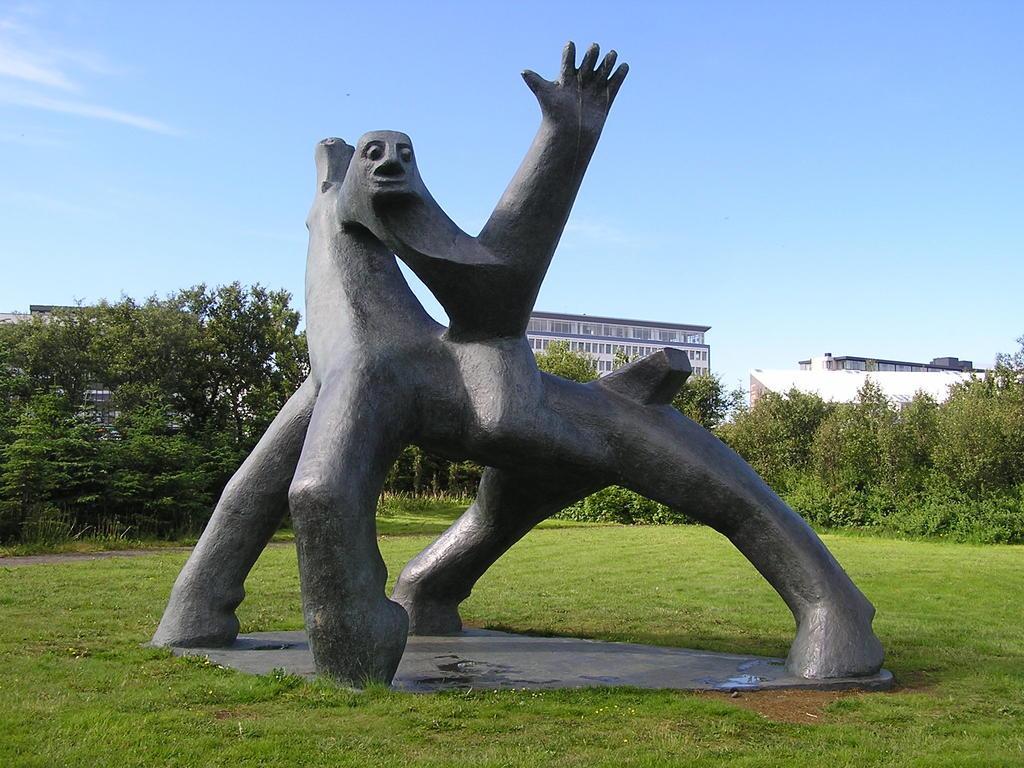Could you give a brief overview of what you see in this image? In this image we can see a statue on the ground and there are few trees, buildings and the sky in the background. 